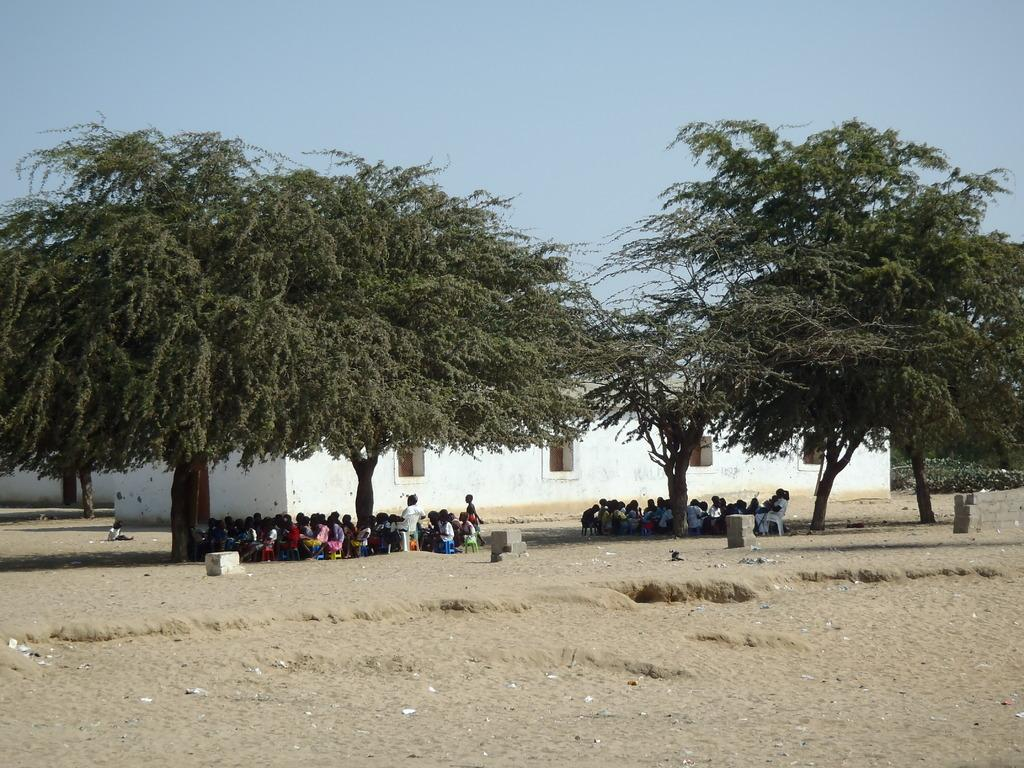What are the people in the image doing? There are persons sitting in the image. What can be seen on the sand in the image? Bricks are present on the sand. What type of vegetation is visible in the image? There are trees in the image. What type of structures can be seen in the image? Buildings are visible in the image. What architectural feature is present in the image? Windows are present in the image. What is visible at the top of the image? The sky is visible in the image. What type of crate is being used to hammer nails into the hobbies in the image? There is no crate, hammer, or hobbies present in the image. 